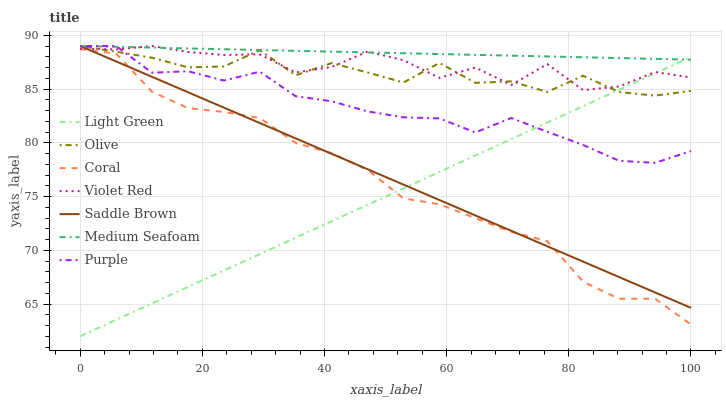Does Light Green have the minimum area under the curve?
Answer yes or no. Yes. Does Medium Seafoam have the maximum area under the curve?
Answer yes or no. Yes. Does Purple have the minimum area under the curve?
Answer yes or no. No. Does Purple have the maximum area under the curve?
Answer yes or no. No. Is Light Green the smoothest?
Answer yes or no. Yes. Is Olive the roughest?
Answer yes or no. Yes. Is Purple the smoothest?
Answer yes or no. No. Is Purple the roughest?
Answer yes or no. No. Does Light Green have the lowest value?
Answer yes or no. Yes. Does Purple have the lowest value?
Answer yes or no. No. Does Medium Seafoam have the highest value?
Answer yes or no. Yes. Does Coral have the highest value?
Answer yes or no. No. Is Coral less than Olive?
Answer yes or no. Yes. Is Violet Red greater than Coral?
Answer yes or no. Yes. Does Light Green intersect Purple?
Answer yes or no. Yes. Is Light Green less than Purple?
Answer yes or no. No. Is Light Green greater than Purple?
Answer yes or no. No. Does Coral intersect Olive?
Answer yes or no. No. 